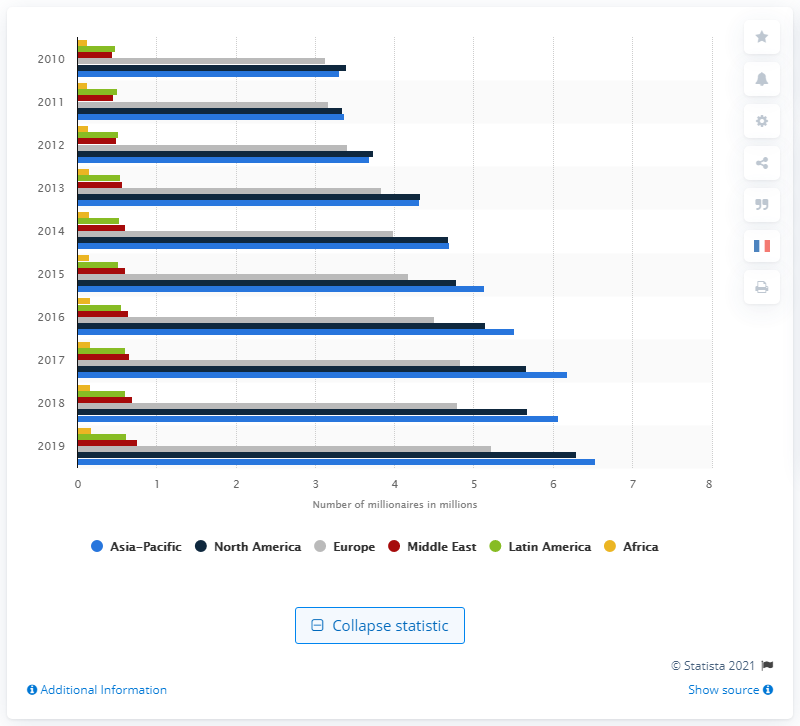What are the trends in the number of millionaires in the Asia Pacific from 2010 to 2019? The number of millionaires in the Asia Pacific region has shown a consistent upward trend from 2010 to 2019. Starting from around 3.1 million in 2010, it dramatically increased year by year, reaching approximately 6.53 million by 2019. 